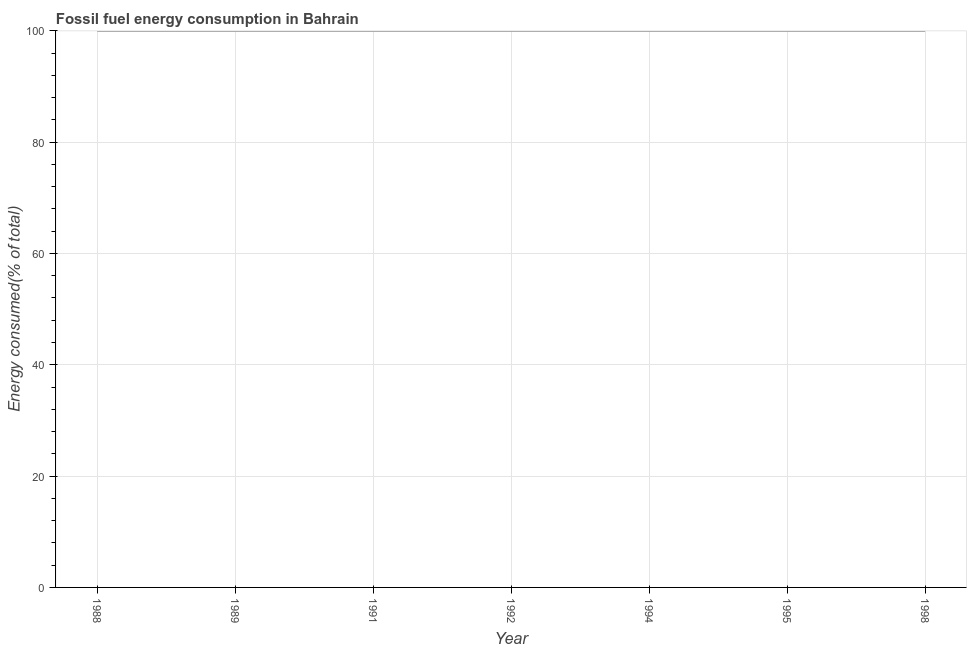What is the fossil fuel energy consumption in 1998?
Ensure brevity in your answer.  100. Across all years, what is the minimum fossil fuel energy consumption?
Your response must be concise. 100. In which year was the fossil fuel energy consumption maximum?
Provide a short and direct response. 1988. In which year was the fossil fuel energy consumption minimum?
Give a very brief answer. 1989. What is the sum of the fossil fuel energy consumption?
Keep it short and to the point. 700. What is the difference between the fossil fuel energy consumption in 1989 and 1998?
Ensure brevity in your answer.  -2.029351730925555e-5. What is the average fossil fuel energy consumption per year?
Your answer should be compact. 100. What is the median fossil fuel energy consumption?
Provide a succinct answer. 100. Do a majority of the years between 1995 and 1988 (inclusive) have fossil fuel energy consumption greater than 8 %?
Make the answer very short. Yes. What is the ratio of the fossil fuel energy consumption in 1989 to that in 1998?
Your answer should be compact. 1. Is the fossil fuel energy consumption in 1991 less than that in 1998?
Your answer should be very brief. Yes. What is the difference between the highest and the second highest fossil fuel energy consumption?
Give a very brief answer. 0. Is the sum of the fossil fuel energy consumption in 1994 and 1998 greater than the maximum fossil fuel energy consumption across all years?
Your answer should be compact. Yes. What is the difference between the highest and the lowest fossil fuel energy consumption?
Give a very brief answer. 2.029351730925555e-5. In how many years, is the fossil fuel energy consumption greater than the average fossil fuel energy consumption taken over all years?
Your response must be concise. 3. How many lines are there?
Provide a succinct answer. 1. What is the difference between two consecutive major ticks on the Y-axis?
Give a very brief answer. 20. Are the values on the major ticks of Y-axis written in scientific E-notation?
Ensure brevity in your answer.  No. Does the graph contain any zero values?
Your response must be concise. No. What is the title of the graph?
Your answer should be compact. Fossil fuel energy consumption in Bahrain. What is the label or title of the X-axis?
Keep it short and to the point. Year. What is the label or title of the Y-axis?
Offer a very short reply. Energy consumed(% of total). What is the Energy consumed(% of total) in 1988?
Your response must be concise. 100. What is the Energy consumed(% of total) in 1989?
Provide a short and direct response. 100. What is the Energy consumed(% of total) in 1991?
Provide a short and direct response. 100. What is the Energy consumed(% of total) in 1994?
Make the answer very short. 100. What is the Energy consumed(% of total) in 1995?
Give a very brief answer. 100. What is the difference between the Energy consumed(% of total) in 1988 and 1989?
Your answer should be compact. 2e-5. What is the difference between the Energy consumed(% of total) in 1988 and 1991?
Give a very brief answer. 2e-5. What is the difference between the Energy consumed(% of total) in 1988 and 1994?
Make the answer very short. 2e-5. What is the difference between the Energy consumed(% of total) in 1988 and 1995?
Offer a very short reply. 2e-5. What is the difference between the Energy consumed(% of total) in 1989 and 1991?
Offer a terse response. -0. What is the difference between the Energy consumed(% of total) in 1989 and 1992?
Provide a succinct answer. -2e-5. What is the difference between the Energy consumed(% of total) in 1989 and 1994?
Your response must be concise. -0. What is the difference between the Energy consumed(% of total) in 1989 and 1995?
Give a very brief answer. -0. What is the difference between the Energy consumed(% of total) in 1989 and 1998?
Offer a very short reply. -2e-5. What is the difference between the Energy consumed(% of total) in 1991 and 1992?
Provide a short and direct response. -2e-5. What is the difference between the Energy consumed(% of total) in 1991 and 1998?
Make the answer very short. -2e-5. What is the difference between the Energy consumed(% of total) in 1992 and 1994?
Your answer should be compact. 2e-5. What is the difference between the Energy consumed(% of total) in 1992 and 1995?
Give a very brief answer. 2e-5. What is the difference between the Energy consumed(% of total) in 1992 and 1998?
Give a very brief answer. 0. What is the difference between the Energy consumed(% of total) in 1994 and 1998?
Your response must be concise. -2e-5. What is the difference between the Energy consumed(% of total) in 1995 and 1998?
Provide a succinct answer. -2e-5. What is the ratio of the Energy consumed(% of total) in 1988 to that in 1994?
Your answer should be compact. 1. What is the ratio of the Energy consumed(% of total) in 1988 to that in 1995?
Give a very brief answer. 1. What is the ratio of the Energy consumed(% of total) in 1988 to that in 1998?
Provide a succinct answer. 1. What is the ratio of the Energy consumed(% of total) in 1989 to that in 1991?
Offer a terse response. 1. What is the ratio of the Energy consumed(% of total) in 1989 to that in 1992?
Ensure brevity in your answer.  1. What is the ratio of the Energy consumed(% of total) in 1989 to that in 1994?
Your answer should be compact. 1. What is the ratio of the Energy consumed(% of total) in 1989 to that in 1995?
Give a very brief answer. 1. What is the ratio of the Energy consumed(% of total) in 1991 to that in 1992?
Keep it short and to the point. 1. What is the ratio of the Energy consumed(% of total) in 1991 to that in 1994?
Keep it short and to the point. 1. What is the ratio of the Energy consumed(% of total) in 1992 to that in 1994?
Provide a short and direct response. 1. What is the ratio of the Energy consumed(% of total) in 1992 to that in 1995?
Give a very brief answer. 1. What is the ratio of the Energy consumed(% of total) in 1992 to that in 1998?
Keep it short and to the point. 1. What is the ratio of the Energy consumed(% of total) in 1994 to that in 1995?
Provide a succinct answer. 1. What is the ratio of the Energy consumed(% of total) in 1994 to that in 1998?
Offer a very short reply. 1. What is the ratio of the Energy consumed(% of total) in 1995 to that in 1998?
Offer a terse response. 1. 